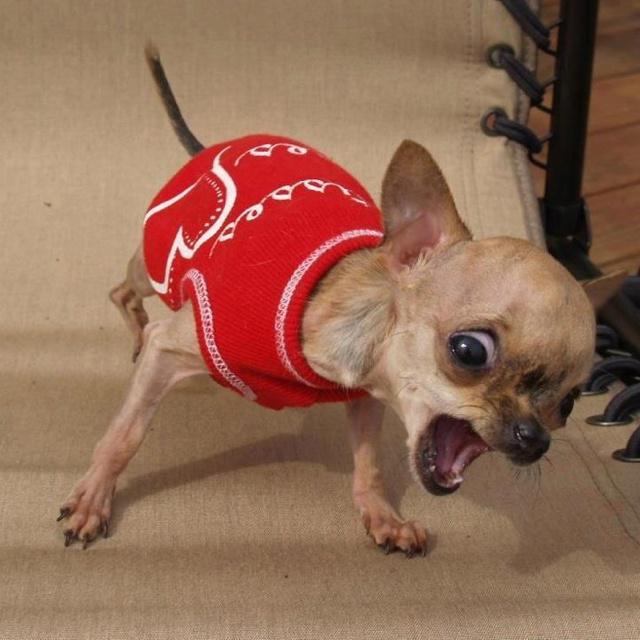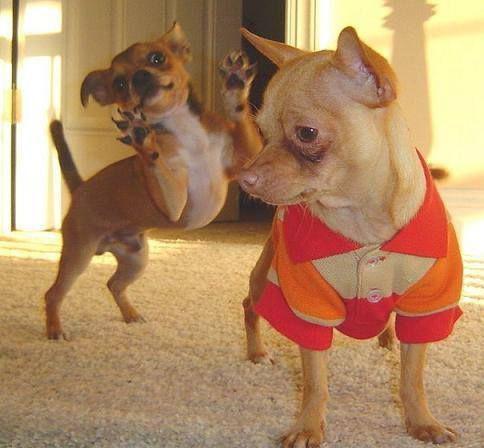The first image is the image on the left, the second image is the image on the right. Evaluate the accuracy of this statement regarding the images: "One of the dogs is outside.". Is it true? Answer yes or no. No. The first image is the image on the left, the second image is the image on the right. For the images shown, is this caption "Each image includes just one dog." true? Answer yes or no. No. 